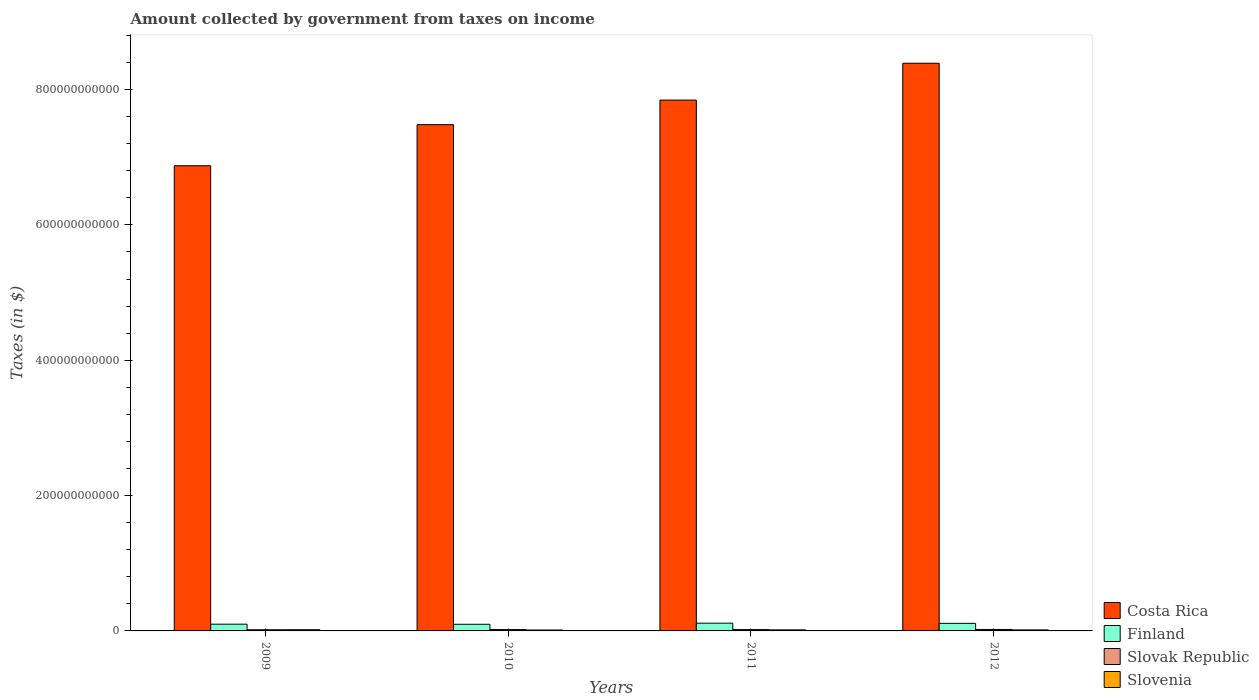How many different coloured bars are there?
Offer a terse response. 4. Are the number of bars on each tick of the X-axis equal?
Keep it short and to the point. Yes. In how many cases, is the number of bars for a given year not equal to the number of legend labels?
Ensure brevity in your answer.  0. What is the amount collected by government from taxes on income in Costa Rica in 2012?
Provide a succinct answer. 8.39e+11. Across all years, what is the maximum amount collected by government from taxes on income in Slovak Republic?
Your response must be concise. 2.16e+09. Across all years, what is the minimum amount collected by government from taxes on income in Costa Rica?
Offer a terse response. 6.87e+11. What is the total amount collected by government from taxes on income in Finland in the graph?
Offer a very short reply. 4.24e+1. What is the difference between the amount collected by government from taxes on income in Slovak Republic in 2009 and that in 2011?
Provide a short and direct response. -2.53e+08. What is the difference between the amount collected by government from taxes on income in Slovak Republic in 2011 and the amount collected by government from taxes on income in Costa Rica in 2010?
Make the answer very short. -7.46e+11. What is the average amount collected by government from taxes on income in Slovak Republic per year?
Your response must be concise. 1.95e+09. In the year 2011, what is the difference between the amount collected by government from taxes on income in Slovenia and amount collected by government from taxes on income in Costa Rica?
Make the answer very short. -7.83e+11. What is the ratio of the amount collected by government from taxes on income in Finland in 2011 to that in 2012?
Provide a short and direct response. 1.02. Is the amount collected by government from taxes on income in Finland in 2009 less than that in 2011?
Provide a succinct answer. Yes. Is the difference between the amount collected by government from taxes on income in Slovenia in 2009 and 2010 greater than the difference between the amount collected by government from taxes on income in Costa Rica in 2009 and 2010?
Make the answer very short. Yes. What is the difference between the highest and the second highest amount collected by government from taxes on income in Costa Rica?
Your response must be concise. 5.44e+1. What is the difference between the highest and the lowest amount collected by government from taxes on income in Slovak Republic?
Make the answer very short. 4.44e+08. In how many years, is the amount collected by government from taxes on income in Slovenia greater than the average amount collected by government from taxes on income in Slovenia taken over all years?
Ensure brevity in your answer.  2. Is the sum of the amount collected by government from taxes on income in Finland in 2010 and 2011 greater than the maximum amount collected by government from taxes on income in Slovak Republic across all years?
Make the answer very short. Yes. What does the 3rd bar from the left in 2012 represents?
Offer a terse response. Slovak Republic. Is it the case that in every year, the sum of the amount collected by government from taxes on income in Slovak Republic and amount collected by government from taxes on income in Costa Rica is greater than the amount collected by government from taxes on income in Slovenia?
Keep it short and to the point. Yes. How many bars are there?
Ensure brevity in your answer.  16. Are all the bars in the graph horizontal?
Your response must be concise. No. How many years are there in the graph?
Offer a very short reply. 4. What is the difference between two consecutive major ticks on the Y-axis?
Ensure brevity in your answer.  2.00e+11. Are the values on the major ticks of Y-axis written in scientific E-notation?
Make the answer very short. No. Where does the legend appear in the graph?
Offer a very short reply. Bottom right. How are the legend labels stacked?
Your answer should be compact. Vertical. What is the title of the graph?
Give a very brief answer. Amount collected by government from taxes on income. What is the label or title of the X-axis?
Provide a short and direct response. Years. What is the label or title of the Y-axis?
Offer a very short reply. Taxes (in $). What is the Taxes (in $) in Costa Rica in 2009?
Your answer should be very brief. 6.87e+11. What is the Taxes (in $) of Finland in 2009?
Your answer should be very brief. 9.97e+09. What is the Taxes (in $) of Slovak Republic in 2009?
Give a very brief answer. 1.71e+09. What is the Taxes (in $) in Slovenia in 2009?
Offer a very short reply. 1.78e+09. What is the Taxes (in $) of Costa Rica in 2010?
Offer a very short reply. 7.48e+11. What is the Taxes (in $) of Finland in 2010?
Your answer should be very brief. 9.82e+09. What is the Taxes (in $) in Slovak Republic in 2010?
Make the answer very short. 1.99e+09. What is the Taxes (in $) in Slovenia in 2010?
Offer a terse response. 1.35e+09. What is the Taxes (in $) in Costa Rica in 2011?
Provide a succinct answer. 7.84e+11. What is the Taxes (in $) of Finland in 2011?
Offer a terse response. 1.14e+1. What is the Taxes (in $) of Slovak Republic in 2011?
Give a very brief answer. 1.96e+09. What is the Taxes (in $) in Slovenia in 2011?
Ensure brevity in your answer.  1.58e+09. What is the Taxes (in $) of Costa Rica in 2012?
Keep it short and to the point. 8.39e+11. What is the Taxes (in $) of Finland in 2012?
Keep it short and to the point. 1.12e+1. What is the Taxes (in $) in Slovak Republic in 2012?
Your answer should be very brief. 2.16e+09. What is the Taxes (in $) of Slovenia in 2012?
Your answer should be very brief. 1.50e+09. Across all years, what is the maximum Taxes (in $) in Costa Rica?
Offer a terse response. 8.39e+11. Across all years, what is the maximum Taxes (in $) of Finland?
Your answer should be compact. 1.14e+1. Across all years, what is the maximum Taxes (in $) in Slovak Republic?
Give a very brief answer. 2.16e+09. Across all years, what is the maximum Taxes (in $) of Slovenia?
Provide a short and direct response. 1.78e+09. Across all years, what is the minimum Taxes (in $) of Costa Rica?
Keep it short and to the point. 6.87e+11. Across all years, what is the minimum Taxes (in $) in Finland?
Give a very brief answer. 9.82e+09. Across all years, what is the minimum Taxes (in $) of Slovak Republic?
Offer a terse response. 1.71e+09. Across all years, what is the minimum Taxes (in $) of Slovenia?
Give a very brief answer. 1.35e+09. What is the total Taxes (in $) of Costa Rica in the graph?
Offer a very short reply. 3.06e+12. What is the total Taxes (in $) of Finland in the graph?
Your answer should be compact. 4.24e+1. What is the total Taxes (in $) in Slovak Republic in the graph?
Make the answer very short. 7.82e+09. What is the total Taxes (in $) of Slovenia in the graph?
Provide a short and direct response. 6.22e+09. What is the difference between the Taxes (in $) in Costa Rica in 2009 and that in 2010?
Your response must be concise. -6.07e+1. What is the difference between the Taxes (in $) in Finland in 2009 and that in 2010?
Give a very brief answer. 1.48e+08. What is the difference between the Taxes (in $) of Slovak Republic in 2009 and that in 2010?
Your answer should be compact. -2.74e+08. What is the difference between the Taxes (in $) of Slovenia in 2009 and that in 2010?
Offer a terse response. 4.34e+08. What is the difference between the Taxes (in $) of Costa Rica in 2009 and that in 2011?
Ensure brevity in your answer.  -9.70e+1. What is the difference between the Taxes (in $) of Finland in 2009 and that in 2011?
Provide a succinct answer. -1.48e+09. What is the difference between the Taxes (in $) in Slovak Republic in 2009 and that in 2011?
Provide a short and direct response. -2.53e+08. What is the difference between the Taxes (in $) in Slovenia in 2009 and that in 2011?
Provide a succinct answer. 2.00e+08. What is the difference between the Taxes (in $) of Costa Rica in 2009 and that in 2012?
Give a very brief answer. -1.51e+11. What is the difference between the Taxes (in $) of Finland in 2009 and that in 2012?
Make the answer very short. -1.23e+09. What is the difference between the Taxes (in $) of Slovak Republic in 2009 and that in 2012?
Keep it short and to the point. -4.44e+08. What is the difference between the Taxes (in $) in Slovenia in 2009 and that in 2012?
Your answer should be very brief. 2.80e+08. What is the difference between the Taxes (in $) in Costa Rica in 2010 and that in 2011?
Give a very brief answer. -3.63e+1. What is the difference between the Taxes (in $) of Finland in 2010 and that in 2011?
Provide a succinct answer. -1.63e+09. What is the difference between the Taxes (in $) in Slovak Republic in 2010 and that in 2011?
Make the answer very short. 2.17e+07. What is the difference between the Taxes (in $) in Slovenia in 2010 and that in 2011?
Give a very brief answer. -2.34e+08. What is the difference between the Taxes (in $) in Costa Rica in 2010 and that in 2012?
Ensure brevity in your answer.  -9.07e+1. What is the difference between the Taxes (in $) of Finland in 2010 and that in 2012?
Ensure brevity in your answer.  -1.38e+09. What is the difference between the Taxes (in $) of Slovak Republic in 2010 and that in 2012?
Give a very brief answer. -1.70e+08. What is the difference between the Taxes (in $) of Slovenia in 2010 and that in 2012?
Your answer should be compact. -1.54e+08. What is the difference between the Taxes (in $) of Costa Rica in 2011 and that in 2012?
Keep it short and to the point. -5.44e+1. What is the difference between the Taxes (in $) in Finland in 2011 and that in 2012?
Keep it short and to the point. 2.53e+08. What is the difference between the Taxes (in $) of Slovak Republic in 2011 and that in 2012?
Your answer should be very brief. -1.91e+08. What is the difference between the Taxes (in $) in Slovenia in 2011 and that in 2012?
Keep it short and to the point. 8.05e+07. What is the difference between the Taxes (in $) of Costa Rica in 2009 and the Taxes (in $) of Finland in 2010?
Offer a terse response. 6.78e+11. What is the difference between the Taxes (in $) of Costa Rica in 2009 and the Taxes (in $) of Slovak Republic in 2010?
Keep it short and to the point. 6.85e+11. What is the difference between the Taxes (in $) of Costa Rica in 2009 and the Taxes (in $) of Slovenia in 2010?
Offer a very short reply. 6.86e+11. What is the difference between the Taxes (in $) of Finland in 2009 and the Taxes (in $) of Slovak Republic in 2010?
Offer a terse response. 7.98e+09. What is the difference between the Taxes (in $) in Finland in 2009 and the Taxes (in $) in Slovenia in 2010?
Your response must be concise. 8.62e+09. What is the difference between the Taxes (in $) in Slovak Republic in 2009 and the Taxes (in $) in Slovenia in 2010?
Your response must be concise. 3.62e+08. What is the difference between the Taxes (in $) of Costa Rica in 2009 and the Taxes (in $) of Finland in 2011?
Your answer should be very brief. 6.76e+11. What is the difference between the Taxes (in $) in Costa Rica in 2009 and the Taxes (in $) in Slovak Republic in 2011?
Ensure brevity in your answer.  6.85e+11. What is the difference between the Taxes (in $) of Costa Rica in 2009 and the Taxes (in $) of Slovenia in 2011?
Your answer should be compact. 6.86e+11. What is the difference between the Taxes (in $) in Finland in 2009 and the Taxes (in $) in Slovak Republic in 2011?
Offer a terse response. 8.00e+09. What is the difference between the Taxes (in $) of Finland in 2009 and the Taxes (in $) of Slovenia in 2011?
Your answer should be compact. 8.38e+09. What is the difference between the Taxes (in $) of Slovak Republic in 2009 and the Taxes (in $) of Slovenia in 2011?
Your answer should be compact. 1.28e+08. What is the difference between the Taxes (in $) of Costa Rica in 2009 and the Taxes (in $) of Finland in 2012?
Keep it short and to the point. 6.76e+11. What is the difference between the Taxes (in $) of Costa Rica in 2009 and the Taxes (in $) of Slovak Republic in 2012?
Your answer should be compact. 6.85e+11. What is the difference between the Taxes (in $) of Costa Rica in 2009 and the Taxes (in $) of Slovenia in 2012?
Keep it short and to the point. 6.86e+11. What is the difference between the Taxes (in $) of Finland in 2009 and the Taxes (in $) of Slovak Republic in 2012?
Your response must be concise. 7.81e+09. What is the difference between the Taxes (in $) of Finland in 2009 and the Taxes (in $) of Slovenia in 2012?
Ensure brevity in your answer.  8.46e+09. What is the difference between the Taxes (in $) in Slovak Republic in 2009 and the Taxes (in $) in Slovenia in 2012?
Give a very brief answer. 2.09e+08. What is the difference between the Taxes (in $) of Costa Rica in 2010 and the Taxes (in $) of Finland in 2011?
Provide a short and direct response. 7.37e+11. What is the difference between the Taxes (in $) of Costa Rica in 2010 and the Taxes (in $) of Slovak Republic in 2011?
Offer a terse response. 7.46e+11. What is the difference between the Taxes (in $) in Costa Rica in 2010 and the Taxes (in $) in Slovenia in 2011?
Ensure brevity in your answer.  7.47e+11. What is the difference between the Taxes (in $) in Finland in 2010 and the Taxes (in $) in Slovak Republic in 2011?
Keep it short and to the point. 7.85e+09. What is the difference between the Taxes (in $) in Finland in 2010 and the Taxes (in $) in Slovenia in 2011?
Your answer should be very brief. 8.23e+09. What is the difference between the Taxes (in $) of Slovak Republic in 2010 and the Taxes (in $) of Slovenia in 2011?
Keep it short and to the point. 4.02e+08. What is the difference between the Taxes (in $) in Costa Rica in 2010 and the Taxes (in $) in Finland in 2012?
Offer a terse response. 7.37e+11. What is the difference between the Taxes (in $) in Costa Rica in 2010 and the Taxes (in $) in Slovak Republic in 2012?
Offer a terse response. 7.46e+11. What is the difference between the Taxes (in $) of Costa Rica in 2010 and the Taxes (in $) of Slovenia in 2012?
Give a very brief answer. 7.47e+11. What is the difference between the Taxes (in $) in Finland in 2010 and the Taxes (in $) in Slovak Republic in 2012?
Ensure brevity in your answer.  7.66e+09. What is the difference between the Taxes (in $) of Finland in 2010 and the Taxes (in $) of Slovenia in 2012?
Provide a short and direct response. 8.31e+09. What is the difference between the Taxes (in $) in Slovak Republic in 2010 and the Taxes (in $) in Slovenia in 2012?
Make the answer very short. 4.83e+08. What is the difference between the Taxes (in $) of Costa Rica in 2011 and the Taxes (in $) of Finland in 2012?
Your response must be concise. 7.73e+11. What is the difference between the Taxes (in $) in Costa Rica in 2011 and the Taxes (in $) in Slovak Republic in 2012?
Provide a short and direct response. 7.82e+11. What is the difference between the Taxes (in $) of Costa Rica in 2011 and the Taxes (in $) of Slovenia in 2012?
Your answer should be compact. 7.83e+11. What is the difference between the Taxes (in $) in Finland in 2011 and the Taxes (in $) in Slovak Republic in 2012?
Make the answer very short. 9.29e+09. What is the difference between the Taxes (in $) of Finland in 2011 and the Taxes (in $) of Slovenia in 2012?
Give a very brief answer. 9.95e+09. What is the difference between the Taxes (in $) in Slovak Republic in 2011 and the Taxes (in $) in Slovenia in 2012?
Make the answer very short. 4.61e+08. What is the average Taxes (in $) in Costa Rica per year?
Offer a very short reply. 7.65e+11. What is the average Taxes (in $) in Finland per year?
Provide a succinct answer. 1.06e+1. What is the average Taxes (in $) of Slovak Republic per year?
Offer a terse response. 1.95e+09. What is the average Taxes (in $) in Slovenia per year?
Keep it short and to the point. 1.56e+09. In the year 2009, what is the difference between the Taxes (in $) of Costa Rica and Taxes (in $) of Finland?
Provide a short and direct response. 6.77e+11. In the year 2009, what is the difference between the Taxes (in $) in Costa Rica and Taxes (in $) in Slovak Republic?
Give a very brief answer. 6.86e+11. In the year 2009, what is the difference between the Taxes (in $) in Costa Rica and Taxes (in $) in Slovenia?
Make the answer very short. 6.86e+11. In the year 2009, what is the difference between the Taxes (in $) in Finland and Taxes (in $) in Slovak Republic?
Your answer should be compact. 8.25e+09. In the year 2009, what is the difference between the Taxes (in $) of Finland and Taxes (in $) of Slovenia?
Make the answer very short. 8.18e+09. In the year 2009, what is the difference between the Taxes (in $) in Slovak Republic and Taxes (in $) in Slovenia?
Your answer should be compact. -7.18e+07. In the year 2010, what is the difference between the Taxes (in $) in Costa Rica and Taxes (in $) in Finland?
Your response must be concise. 7.38e+11. In the year 2010, what is the difference between the Taxes (in $) of Costa Rica and Taxes (in $) of Slovak Republic?
Provide a succinct answer. 7.46e+11. In the year 2010, what is the difference between the Taxes (in $) of Costa Rica and Taxes (in $) of Slovenia?
Make the answer very short. 7.47e+11. In the year 2010, what is the difference between the Taxes (in $) in Finland and Taxes (in $) in Slovak Republic?
Offer a very short reply. 7.83e+09. In the year 2010, what is the difference between the Taxes (in $) in Finland and Taxes (in $) in Slovenia?
Keep it short and to the point. 8.47e+09. In the year 2010, what is the difference between the Taxes (in $) in Slovak Republic and Taxes (in $) in Slovenia?
Offer a terse response. 6.36e+08. In the year 2011, what is the difference between the Taxes (in $) in Costa Rica and Taxes (in $) in Finland?
Offer a very short reply. 7.73e+11. In the year 2011, what is the difference between the Taxes (in $) in Costa Rica and Taxes (in $) in Slovak Republic?
Keep it short and to the point. 7.82e+11. In the year 2011, what is the difference between the Taxes (in $) of Costa Rica and Taxes (in $) of Slovenia?
Provide a short and direct response. 7.83e+11. In the year 2011, what is the difference between the Taxes (in $) in Finland and Taxes (in $) in Slovak Republic?
Give a very brief answer. 9.49e+09. In the year 2011, what is the difference between the Taxes (in $) in Finland and Taxes (in $) in Slovenia?
Make the answer very short. 9.87e+09. In the year 2011, what is the difference between the Taxes (in $) of Slovak Republic and Taxes (in $) of Slovenia?
Your answer should be compact. 3.81e+08. In the year 2012, what is the difference between the Taxes (in $) in Costa Rica and Taxes (in $) in Finland?
Give a very brief answer. 8.28e+11. In the year 2012, what is the difference between the Taxes (in $) in Costa Rica and Taxes (in $) in Slovak Republic?
Ensure brevity in your answer.  8.37e+11. In the year 2012, what is the difference between the Taxes (in $) of Costa Rica and Taxes (in $) of Slovenia?
Your answer should be compact. 8.37e+11. In the year 2012, what is the difference between the Taxes (in $) of Finland and Taxes (in $) of Slovak Republic?
Make the answer very short. 9.04e+09. In the year 2012, what is the difference between the Taxes (in $) of Finland and Taxes (in $) of Slovenia?
Make the answer very short. 9.69e+09. In the year 2012, what is the difference between the Taxes (in $) of Slovak Republic and Taxes (in $) of Slovenia?
Provide a short and direct response. 6.53e+08. What is the ratio of the Taxes (in $) of Costa Rica in 2009 to that in 2010?
Provide a succinct answer. 0.92. What is the ratio of the Taxes (in $) of Finland in 2009 to that in 2010?
Your answer should be compact. 1.02. What is the ratio of the Taxes (in $) in Slovak Republic in 2009 to that in 2010?
Your answer should be compact. 0.86. What is the ratio of the Taxes (in $) of Slovenia in 2009 to that in 2010?
Provide a succinct answer. 1.32. What is the ratio of the Taxes (in $) of Costa Rica in 2009 to that in 2011?
Keep it short and to the point. 0.88. What is the ratio of the Taxes (in $) in Finland in 2009 to that in 2011?
Your answer should be compact. 0.87. What is the ratio of the Taxes (in $) in Slovak Republic in 2009 to that in 2011?
Keep it short and to the point. 0.87. What is the ratio of the Taxes (in $) in Slovenia in 2009 to that in 2011?
Keep it short and to the point. 1.13. What is the ratio of the Taxes (in $) in Costa Rica in 2009 to that in 2012?
Ensure brevity in your answer.  0.82. What is the ratio of the Taxes (in $) in Finland in 2009 to that in 2012?
Your response must be concise. 0.89. What is the ratio of the Taxes (in $) in Slovak Republic in 2009 to that in 2012?
Provide a succinct answer. 0.79. What is the ratio of the Taxes (in $) in Slovenia in 2009 to that in 2012?
Offer a terse response. 1.19. What is the ratio of the Taxes (in $) in Costa Rica in 2010 to that in 2011?
Your answer should be very brief. 0.95. What is the ratio of the Taxes (in $) of Finland in 2010 to that in 2011?
Make the answer very short. 0.86. What is the ratio of the Taxes (in $) of Slovak Republic in 2010 to that in 2011?
Offer a terse response. 1.01. What is the ratio of the Taxes (in $) of Slovenia in 2010 to that in 2011?
Your answer should be compact. 0.85. What is the ratio of the Taxes (in $) in Costa Rica in 2010 to that in 2012?
Your answer should be very brief. 0.89. What is the ratio of the Taxes (in $) of Finland in 2010 to that in 2012?
Provide a succinct answer. 0.88. What is the ratio of the Taxes (in $) of Slovak Republic in 2010 to that in 2012?
Make the answer very short. 0.92. What is the ratio of the Taxes (in $) of Slovenia in 2010 to that in 2012?
Give a very brief answer. 0.9. What is the ratio of the Taxes (in $) in Costa Rica in 2011 to that in 2012?
Keep it short and to the point. 0.94. What is the ratio of the Taxes (in $) of Finland in 2011 to that in 2012?
Make the answer very short. 1.02. What is the ratio of the Taxes (in $) in Slovak Republic in 2011 to that in 2012?
Your answer should be very brief. 0.91. What is the ratio of the Taxes (in $) in Slovenia in 2011 to that in 2012?
Offer a terse response. 1.05. What is the difference between the highest and the second highest Taxes (in $) in Costa Rica?
Your answer should be very brief. 5.44e+1. What is the difference between the highest and the second highest Taxes (in $) of Finland?
Your response must be concise. 2.53e+08. What is the difference between the highest and the second highest Taxes (in $) in Slovak Republic?
Provide a short and direct response. 1.70e+08. What is the difference between the highest and the second highest Taxes (in $) of Slovenia?
Give a very brief answer. 2.00e+08. What is the difference between the highest and the lowest Taxes (in $) in Costa Rica?
Offer a very short reply. 1.51e+11. What is the difference between the highest and the lowest Taxes (in $) in Finland?
Your answer should be compact. 1.63e+09. What is the difference between the highest and the lowest Taxes (in $) of Slovak Republic?
Provide a succinct answer. 4.44e+08. What is the difference between the highest and the lowest Taxes (in $) in Slovenia?
Give a very brief answer. 4.34e+08. 